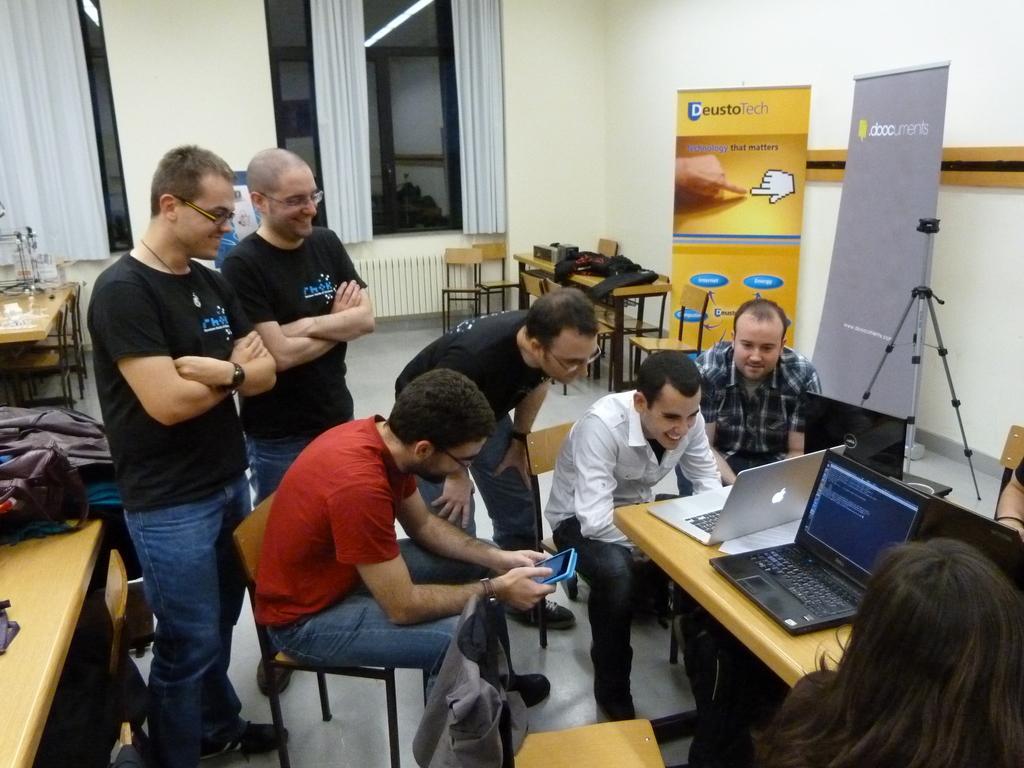Could you give a brief overview of what you see in this image? This is a picture taken in a restaurant, there are a group of people some people are standing on the floor and some are sitting on a chair in front of the people there is a table on the table there are laptops. Background of this people is a banners, glass window and a wall. 